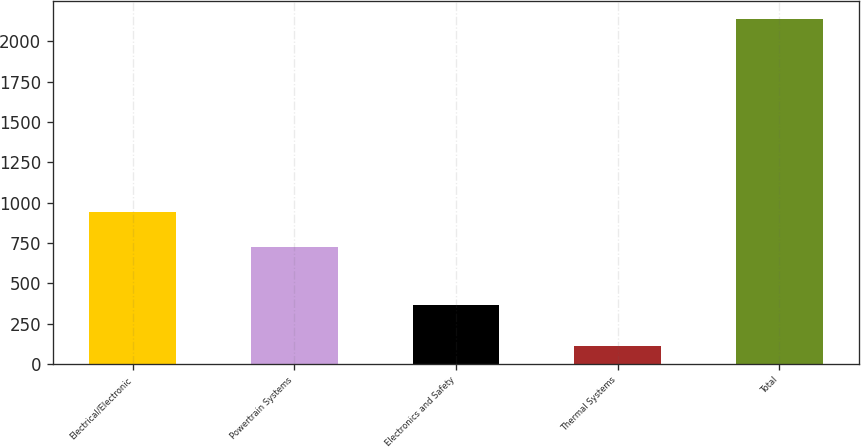Convert chart to OTSL. <chart><loc_0><loc_0><loc_500><loc_500><bar_chart><fcel>Electrical/Electronic<fcel>Powertrain Systems<fcel>Electronics and Safety<fcel>Thermal Systems<fcel>Total<nl><fcel>945<fcel>723<fcel>363<fcel>111<fcel>2142<nl></chart> 